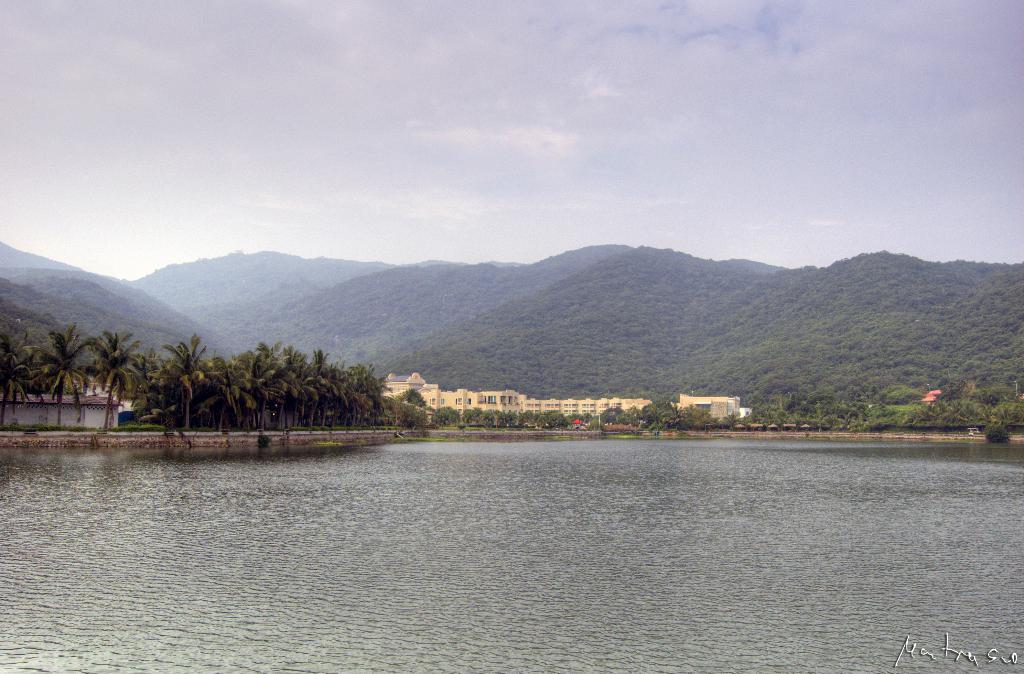What is the primary element visible in the image? Water is visible in the image. What type of natural vegetation can be seen in the image? There are many trees in the image. What structures are visible in the background of the image? There are buildings in the background of the image. What type of geographical features can be seen in the background of the image? There are mountains in the background of the image. What part of the natural environment is visible in the background of the image? The sky is visible in the background of the image. What type of bread can be seen on the mountain in the image? There is no bread present in the image, and no bread can be seen on the mountain. 